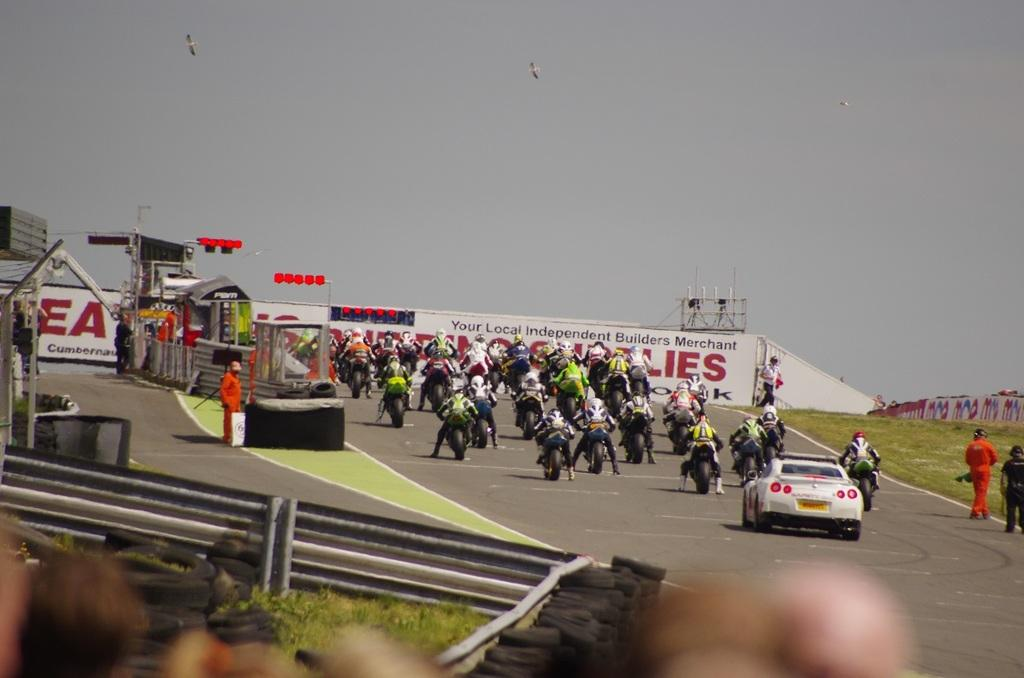<image>
Relay a brief, clear account of the picture shown. A large group of people on motorcycles are near a large building advertising a local builders merchant. 